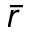<formula> <loc_0><loc_0><loc_500><loc_500>\bar { r }</formula> 